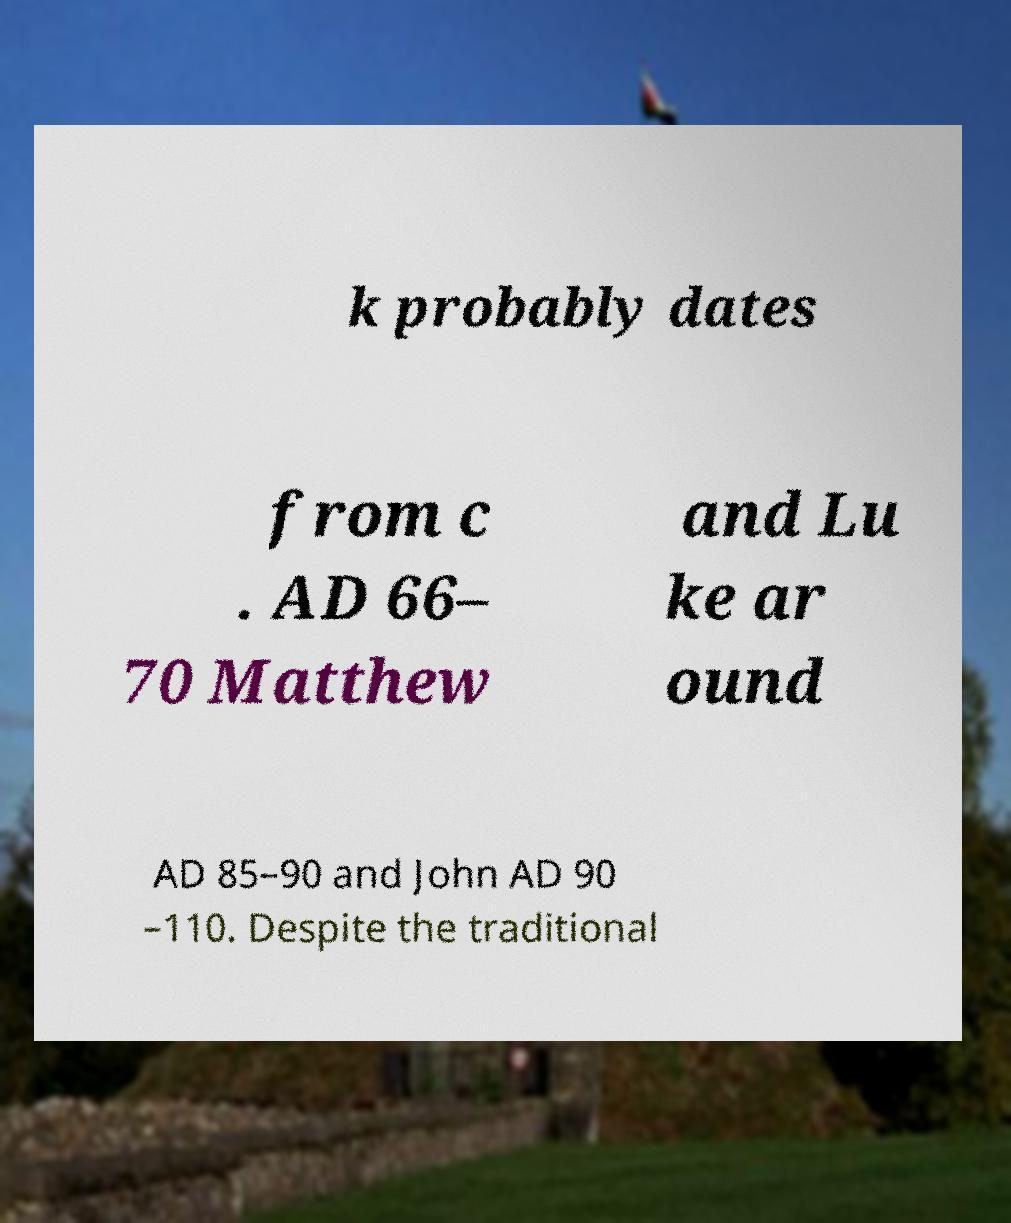Could you assist in decoding the text presented in this image and type it out clearly? k probably dates from c . AD 66– 70 Matthew and Lu ke ar ound AD 85–90 and John AD 90 –110. Despite the traditional 